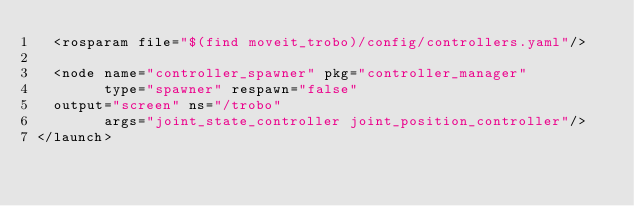<code> <loc_0><loc_0><loc_500><loc_500><_XML_>  <rosparam file="$(find moveit_trobo)/config/controllers.yaml"/>
  
  <node name="controller_spawner" pkg="controller_manager" 
        type="spawner" respawn="false"
	output="screen" ns="/trobo"
        args="joint_state_controller joint_position_controller"/> 
</launch>
</code> 